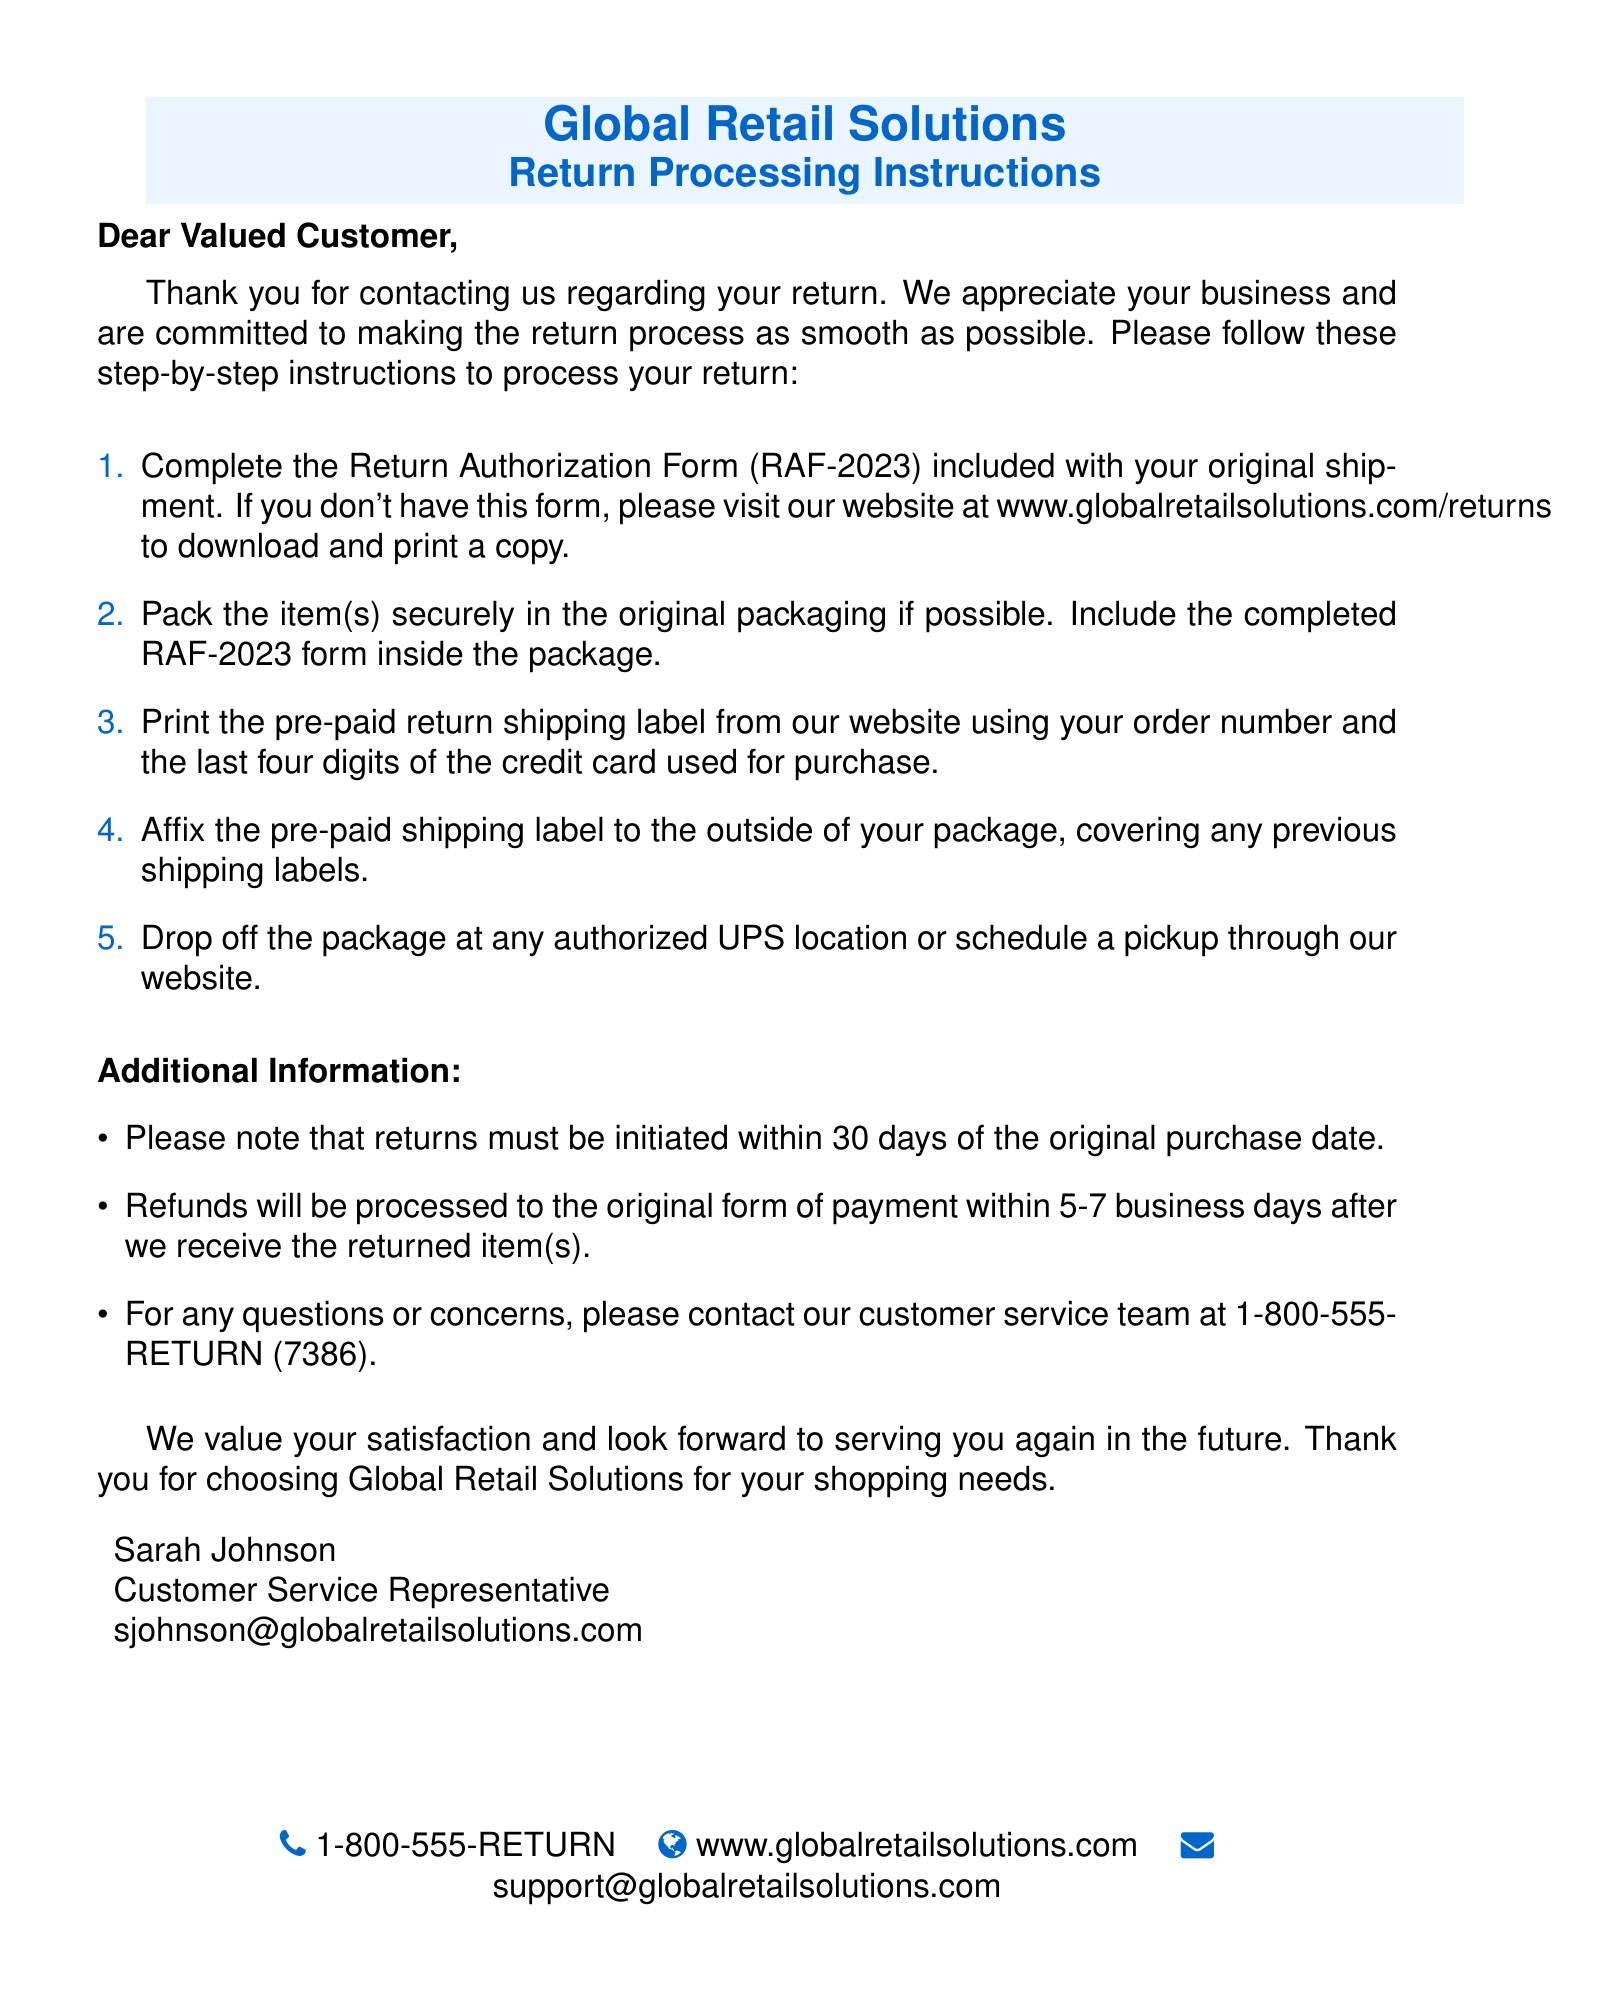What is the return authorization form number? The return authorization form number is mentioned as RAF-2023 in the document.
Answer: RAF-2023 Where can I download a copy of the Return Authorization Form? The document specifies that a copy can be downloaded from the website at www.globalretailsolutions.com/returns.
Answer: www.globalretailsolutions.com/returns How many days do I have to initiate a return? The document states that returns must be initiated within 30 days of the original purchase date.
Answer: 30 days What is the phone number for customer service? The customer service phone number provided in the document is clearly stated as 1-800-555-RETURN.
Answer: 1-800-555-RETURN How long will it take to process my refund? The document indicates that refunds will be processed within 5-7 business days after the returned item(s) are received.
Answer: 5-7 business days What should I do if I don’t have the Return Authorization Form? The document tells customers to visit the website to download and print a copy if they don't have the form.
Answer: Visit the website What should be included inside the return package? The instructions specify that the completed Return Authorization Form (RAF-2023) should be included inside the package.
Answer: Completed RAF-2023 form Which courier service should I use to return the package? The document advises dropping off the package at any authorized UPS location or scheduling a pickup.
Answer: UPS 